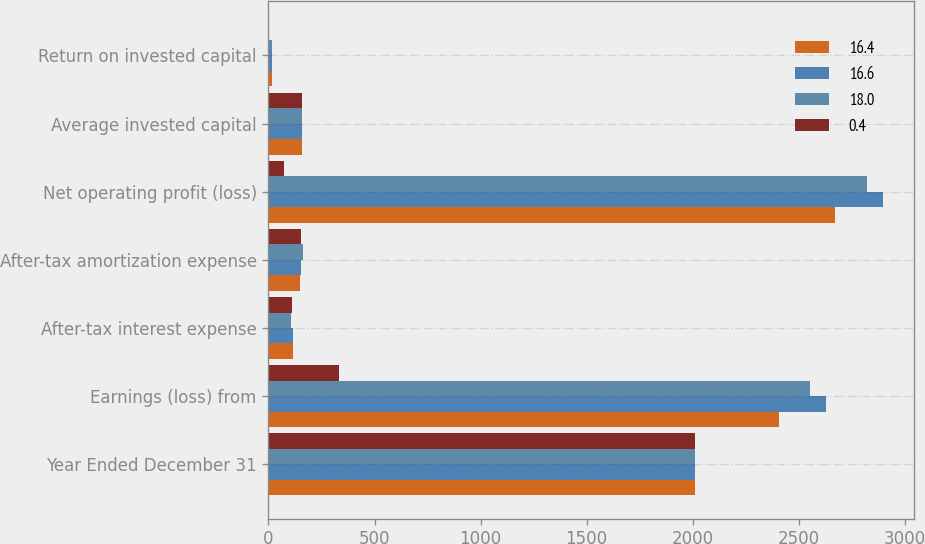Convert chart. <chart><loc_0><loc_0><loc_500><loc_500><stacked_bar_chart><ecel><fcel>Year Ended December 31<fcel>Earnings (loss) from<fcel>After-tax interest expense<fcel>After-tax amortization expense<fcel>Net operating profit (loss)<fcel>Average invested capital<fcel>Return on invested capital<nl><fcel>16.4<fcel>2009<fcel>2407<fcel>117<fcel>149<fcel>2673<fcel>159<fcel>18<nl><fcel>16.6<fcel>2010<fcel>2628<fcel>116<fcel>155<fcel>2899<fcel>159<fcel>17.4<nl><fcel>18<fcel>2011<fcel>2552<fcel>106<fcel>163<fcel>2821<fcel>159<fcel>16.4<nl><fcel>0.4<fcel>2012<fcel>332<fcel>109<fcel>152<fcel>71<fcel>159<fcel>0.4<nl></chart> 